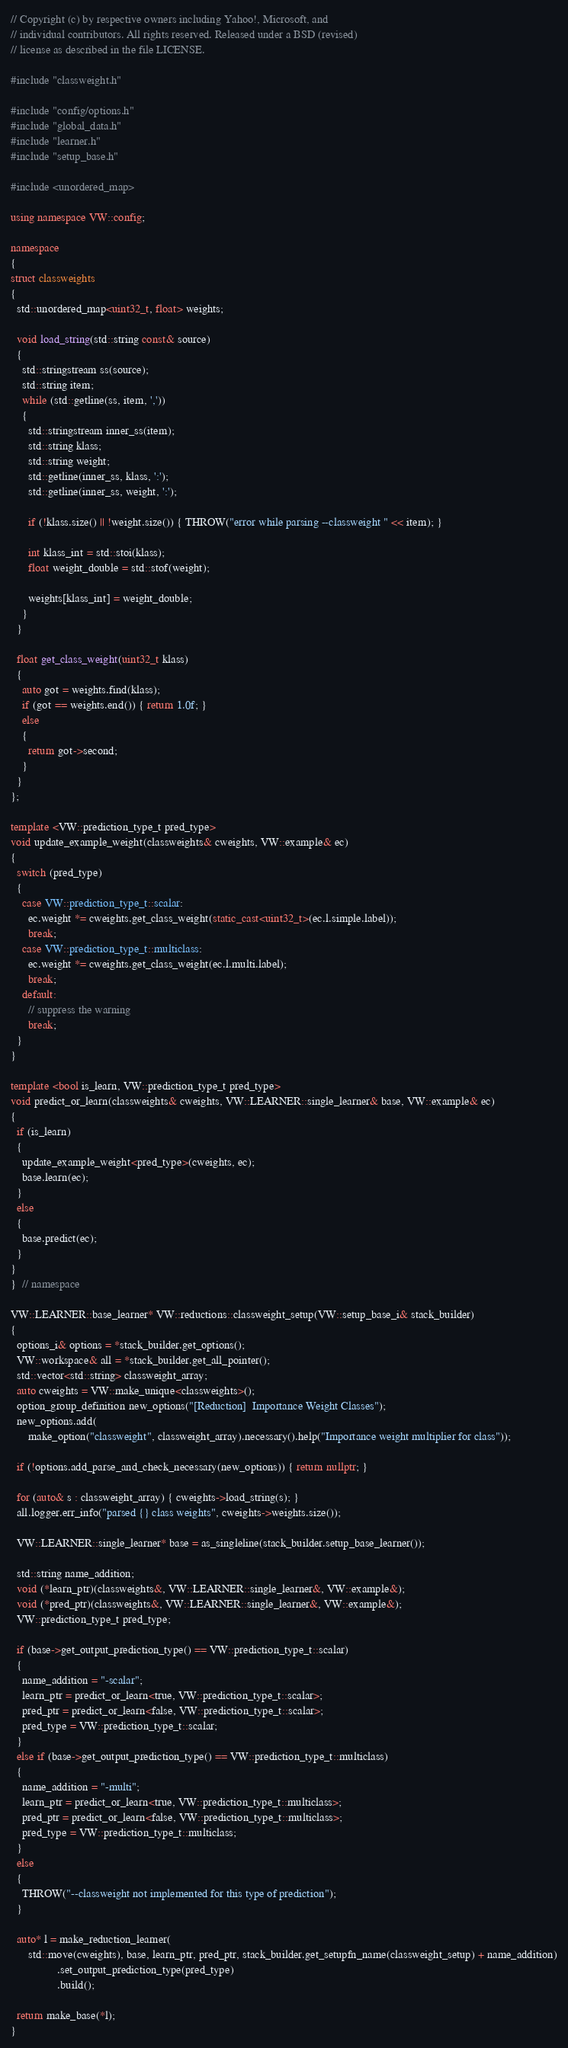Convert code to text. <code><loc_0><loc_0><loc_500><loc_500><_C++_>// Copyright (c) by respective owners including Yahoo!, Microsoft, and
// individual contributors. All rights reserved. Released under a BSD (revised)
// license as described in the file LICENSE.

#include "classweight.h"

#include "config/options.h"
#include "global_data.h"
#include "learner.h"
#include "setup_base.h"

#include <unordered_map>

using namespace VW::config;

namespace
{
struct classweights
{
  std::unordered_map<uint32_t, float> weights;

  void load_string(std::string const& source)
  {
    std::stringstream ss(source);
    std::string item;
    while (std::getline(ss, item, ','))
    {
      std::stringstream inner_ss(item);
      std::string klass;
      std::string weight;
      std::getline(inner_ss, klass, ':');
      std::getline(inner_ss, weight, ':');

      if (!klass.size() || !weight.size()) { THROW("error while parsing --classweight " << item); }

      int klass_int = std::stoi(klass);
      float weight_double = std::stof(weight);

      weights[klass_int] = weight_double;
    }
  }

  float get_class_weight(uint32_t klass)
  {
    auto got = weights.find(klass);
    if (got == weights.end()) { return 1.0f; }
    else
    {
      return got->second;
    }
  }
};

template <VW::prediction_type_t pred_type>
void update_example_weight(classweights& cweights, VW::example& ec)
{
  switch (pred_type)
  {
    case VW::prediction_type_t::scalar:
      ec.weight *= cweights.get_class_weight(static_cast<uint32_t>(ec.l.simple.label));
      break;
    case VW::prediction_type_t::multiclass:
      ec.weight *= cweights.get_class_weight(ec.l.multi.label);
      break;
    default:
      // suppress the warning
      break;
  }
}

template <bool is_learn, VW::prediction_type_t pred_type>
void predict_or_learn(classweights& cweights, VW::LEARNER::single_learner& base, VW::example& ec)
{
  if (is_learn)
  {
    update_example_weight<pred_type>(cweights, ec);
    base.learn(ec);
  }
  else
  {
    base.predict(ec);
  }
}
}  // namespace

VW::LEARNER::base_learner* VW::reductions::classweight_setup(VW::setup_base_i& stack_builder)
{
  options_i& options = *stack_builder.get_options();
  VW::workspace& all = *stack_builder.get_all_pointer();
  std::vector<std::string> classweight_array;
  auto cweights = VW::make_unique<classweights>();
  option_group_definition new_options("[Reduction]  Importance Weight Classes");
  new_options.add(
      make_option("classweight", classweight_array).necessary().help("Importance weight multiplier for class"));

  if (!options.add_parse_and_check_necessary(new_options)) { return nullptr; }

  for (auto& s : classweight_array) { cweights->load_string(s); }
  all.logger.err_info("parsed {} class weights", cweights->weights.size());

  VW::LEARNER::single_learner* base = as_singleline(stack_builder.setup_base_learner());

  std::string name_addition;
  void (*learn_ptr)(classweights&, VW::LEARNER::single_learner&, VW::example&);
  void (*pred_ptr)(classweights&, VW::LEARNER::single_learner&, VW::example&);
  VW::prediction_type_t pred_type;

  if (base->get_output_prediction_type() == VW::prediction_type_t::scalar)
  {
    name_addition = "-scalar";
    learn_ptr = predict_or_learn<true, VW::prediction_type_t::scalar>;
    pred_ptr = predict_or_learn<false, VW::prediction_type_t::scalar>;
    pred_type = VW::prediction_type_t::scalar;
  }
  else if (base->get_output_prediction_type() == VW::prediction_type_t::multiclass)
  {
    name_addition = "-multi";
    learn_ptr = predict_or_learn<true, VW::prediction_type_t::multiclass>;
    pred_ptr = predict_or_learn<false, VW::prediction_type_t::multiclass>;
    pred_type = VW::prediction_type_t::multiclass;
  }
  else
  {
    THROW("--classweight not implemented for this type of prediction");
  }

  auto* l = make_reduction_learner(
      std::move(cweights), base, learn_ptr, pred_ptr, stack_builder.get_setupfn_name(classweight_setup) + name_addition)
                .set_output_prediction_type(pred_type)
                .build();

  return make_base(*l);
}
</code> 